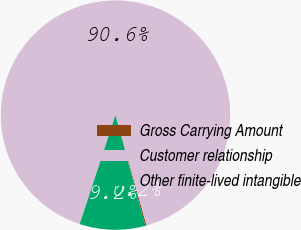Convert chart. <chart><loc_0><loc_0><loc_500><loc_500><pie_chart><fcel>Gross Carrying Amount<fcel>Customer relationship<fcel>Other finite-lived intangible<nl><fcel>0.19%<fcel>90.57%<fcel>9.23%<nl></chart> 